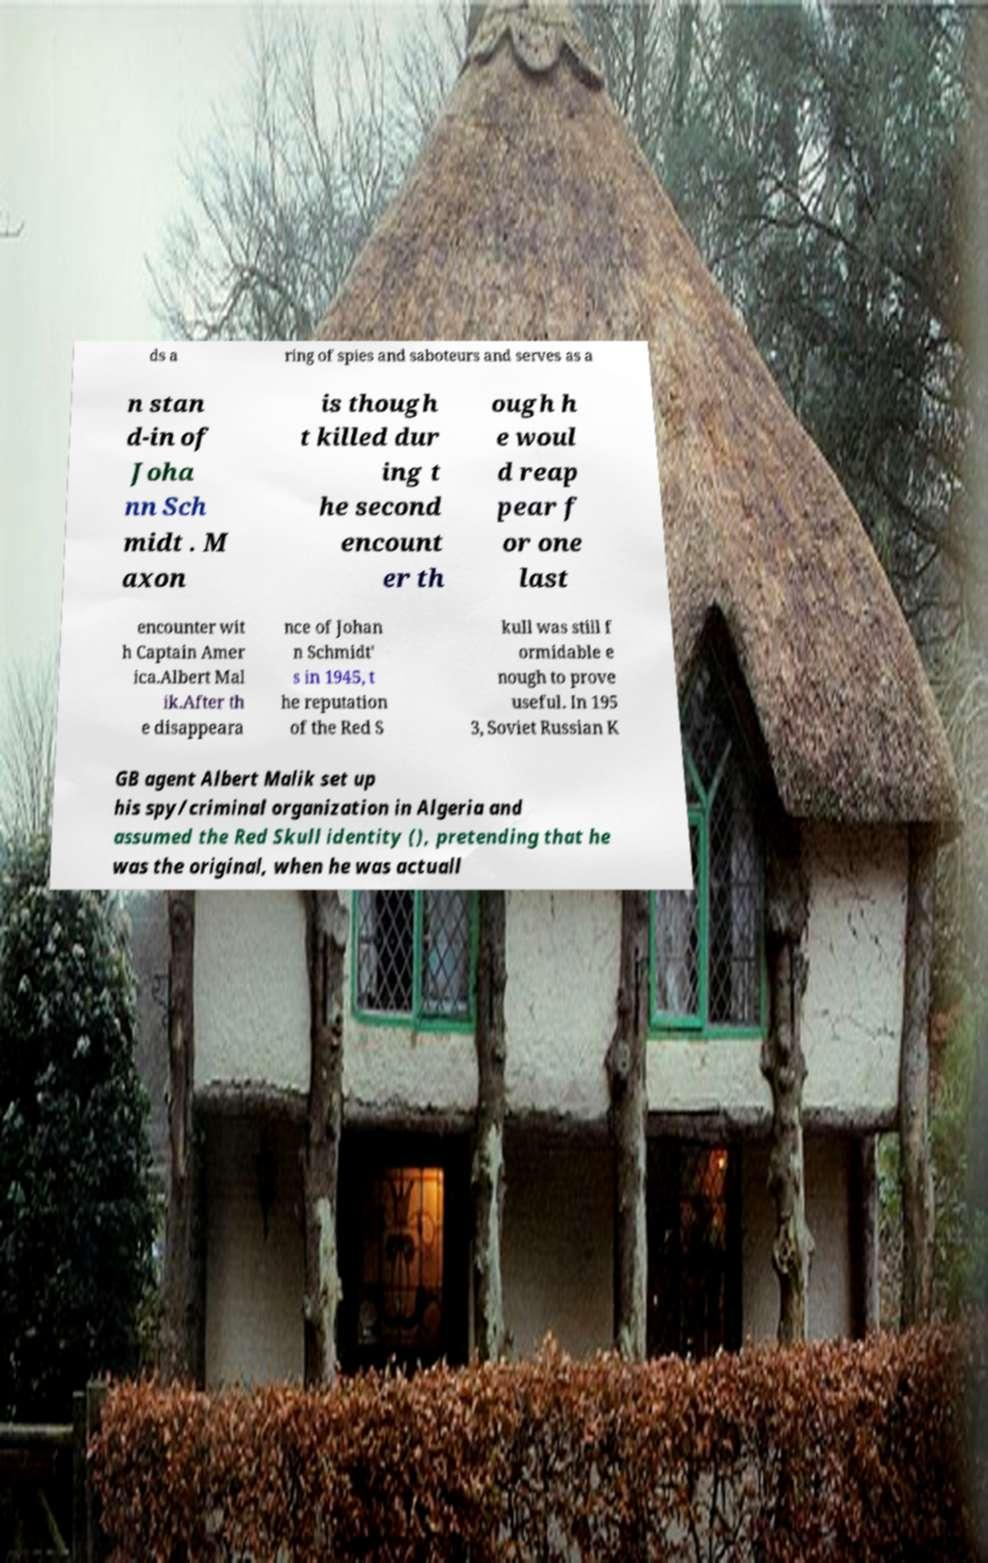Can you accurately transcribe the text from the provided image for me? ds a ring of spies and saboteurs and serves as a n stan d-in of Joha nn Sch midt . M axon is though t killed dur ing t he second encount er th ough h e woul d reap pear f or one last encounter wit h Captain Amer ica.Albert Mal ik.After th e disappeara nce of Johan n Schmidt' s in 1945, t he reputation of the Red S kull was still f ormidable e nough to prove useful. In 195 3, Soviet Russian K GB agent Albert Malik set up his spy/criminal organization in Algeria and assumed the Red Skull identity (), pretending that he was the original, when he was actuall 